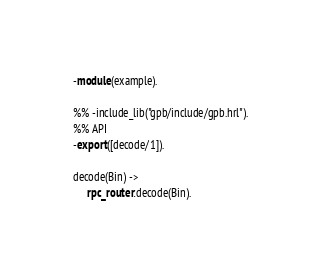Convert code to text. <code><loc_0><loc_0><loc_500><loc_500><_Erlang_>-module(example).

%% -include_lib("gpb/include/gpb.hrl").
%% API
-export([decode/1]).

decode(Bin) ->
     rpc_router:decode(Bin).

</code> 